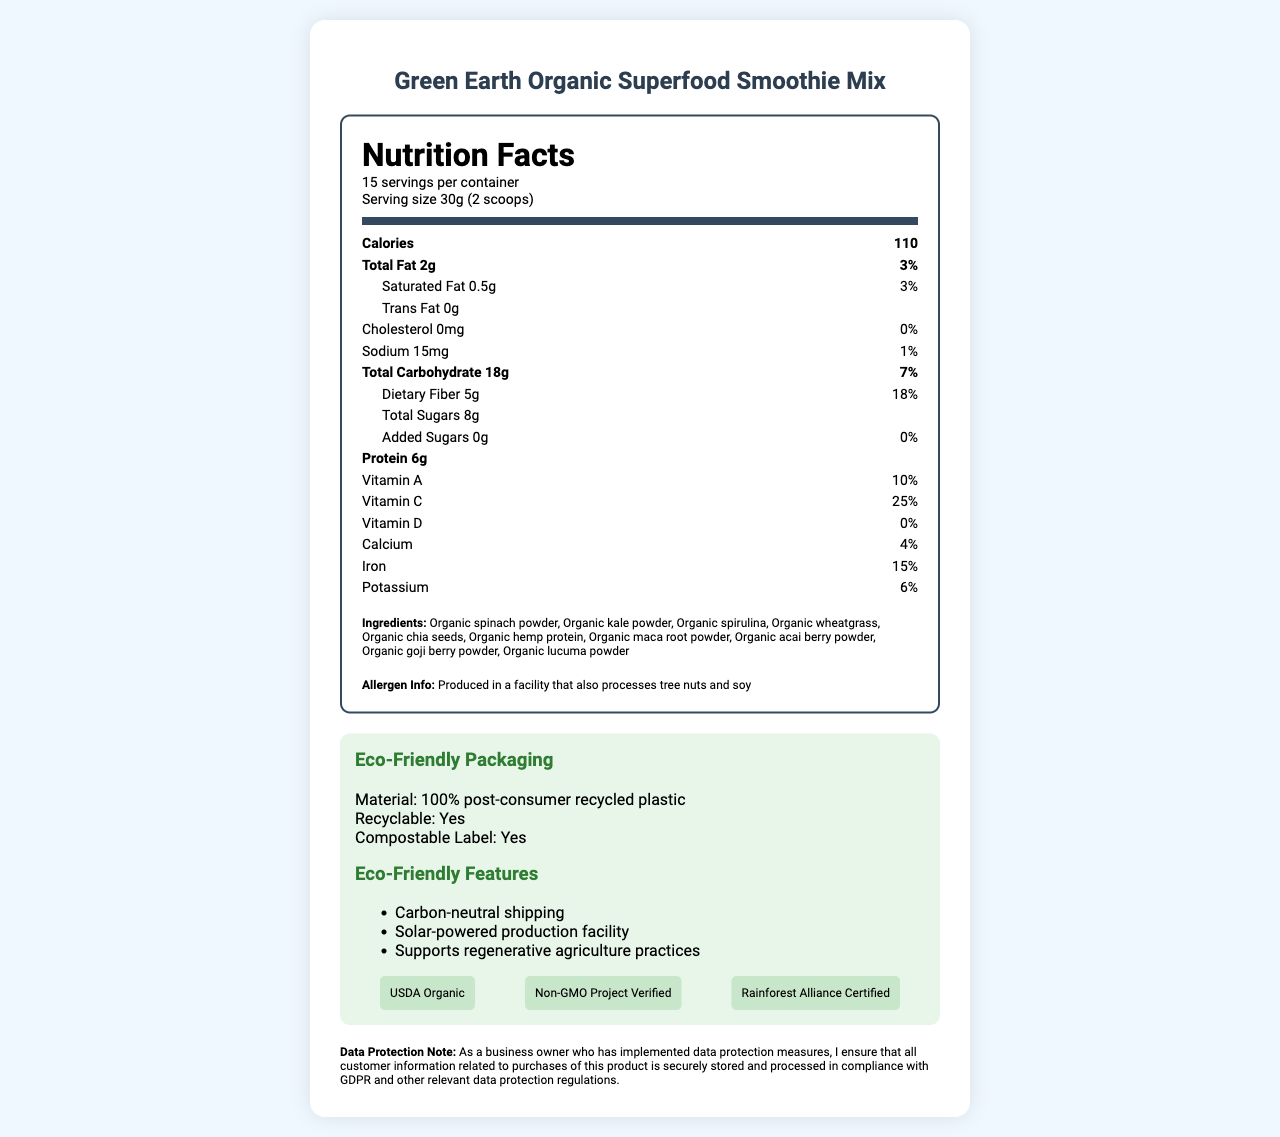who is the manufacturer of the product? The document does not mention the manufacturer of the Green Earth Organic Superfood Smoothie Mix.
Answer: Cannot be determined what are the serving size and the number of servings per container? The serving size is mentioned as 30g (2 scoops), and there are 15 servings per container as specified at the top of the nutrition label.
Answer: 30g (2 scoops), 15 servings how much dietary fiber is in one serving of the product? The nutrition facts table lists dietary fiber content as 5g per serving.
Answer: 5g what is the daily value percentage of vitamin C in this product? The nutrition facts table under vitamins lists vitamin C with a daily value of 25%.
Answer: 25% are there any added sugars in this product? The nutrition label specifies that there are 0g of added sugars in the product.
Answer: No what eco-friendly certifications does this product have? These certifications are listed in the "certification-list" section of the document.
Answer: USDA Organic, Non-GMO Project Verified, Rainforest Alliance Certified where is this product produced, considering its eco-friendly features? A. Wind-powered facility B. Off-grid facility C. Solar-powered production facility D. Hydropower facility The document mentions that one of the eco-friendly features is a solar-powered production facility.
Answer: C which ingredient is NOT present in this product? A. Organic spinach powder B. Organic spirulina C. Organic macadamia nuts D. Organic lucuma powder The ingredients list does not include organic macadamia nuts.
Answer: C how is the packaging of this product described? The eco-info section of the document describes the packaging.
Answer: 100% post-consumer recycled plastic, recyclable, compostable label does the product comply with GDPR for customer data protection? The business owner note explicitly states compliance with GDPR and other relevant data protection regulations.
Answer: Yes summarize the key features of the Green Earth Organic Superfood Smoothie Mix. The document provides a nutritional profile, ingredient list, eco-friendly packaging details, certifications, sustainability efforts, and data protection measures.
Answer: The Green Earth Organic Superfood Smoothie Mix is a nutritious product with 110 calories per serving, containing various organic superfood ingredients like spinach powder, kale powder, and spirulina. The packaging is eco-friendly, made from 100% post-consumer recycled plastic, and is recyclable and compostable. It holds multiple eco-certifications and employs sustainability practices such as carbon-neutral shipping and solar-powered production. The business ensures GDPR compliance for customer data protection. what is the total fat content per serving, and what percentage of the daily value does it represent? The nutrition facts table lists total fat content as 2g per serving, representing 3% of the daily value.
Answer: 2g, 3% 